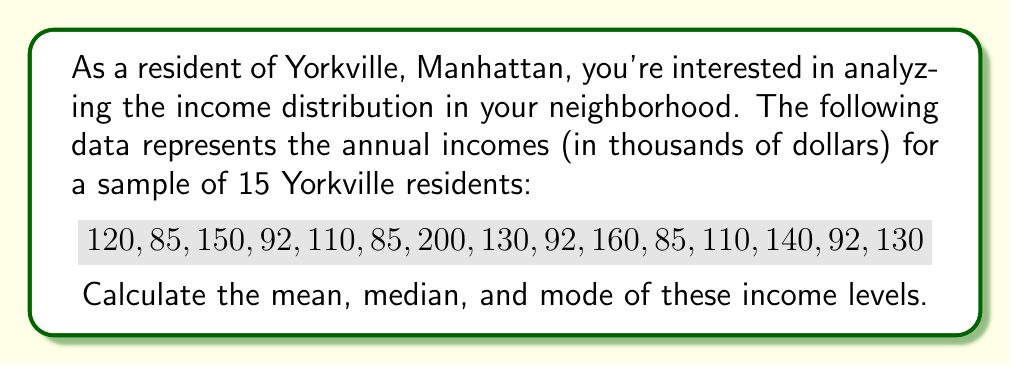Teach me how to tackle this problem. Let's approach this step-by-step:

1. Mean:
   The mean is the average of all values.
   
   $$\text{Mean} = \frac{\sum_{i=1}^{n} x_i}{n}$$
   
   where $x_i$ are the individual values and $n$ is the number of values.
   
   $$\text{Mean} = \frac{120 + 85 + 150 + 92 + 110 + 85 + 200 + 130 + 92 + 160 + 85 + 110 + 140 + 92 + 130}{15}$$
   
   $$= \frac{1781}{15} \approx 118.73$$

2. Median:
   First, arrange the data in ascending order:
   
   $85, 85, 85, 92, 92, 92, 110, 110, 120, 130, 130, 140, 150, 160, 200$
   
   With 15 values, the median is the 8th value (middle value).
   
   $$\text{Median} = 110$$

3. Mode:
   The mode is the value that appears most frequently.
   
   $85$ appears 3 times
   $92$ appears 3 times
   $110$ appears 2 times
   All other values appear once
   
   Therefore, there are two modes: $85$ and $92$
Answer: Mean: $\$118,730$
Median: $\$110,000$
Mode: $\$85,000$ and $\$92,000$ (bimodal) 